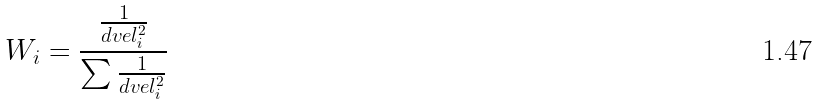Convert formula to latex. <formula><loc_0><loc_0><loc_500><loc_500>W _ { i } = \frac { \frac { 1 } { d v e l _ { i } ^ { 2 } } } { \sum \frac { 1 } { d v e l _ { i } ^ { 2 } } }</formula> 